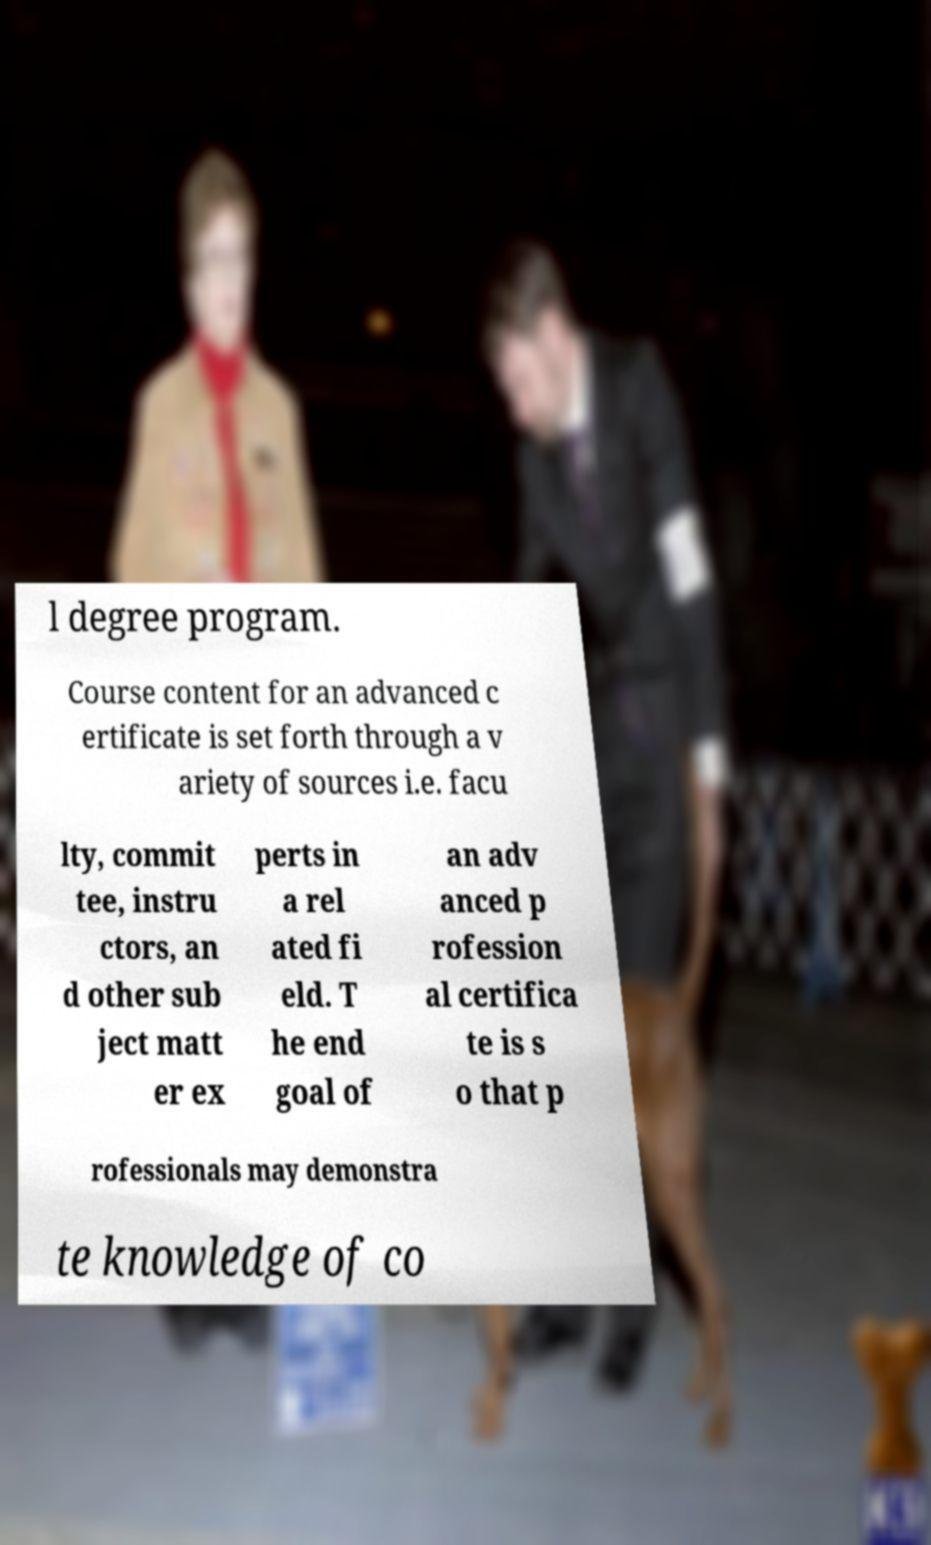Could you extract and type out the text from this image? l degree program. Course content for an advanced c ertificate is set forth through a v ariety of sources i.e. facu lty, commit tee, instru ctors, an d other sub ject matt er ex perts in a rel ated fi eld. T he end goal of an adv anced p rofession al certifica te is s o that p rofessionals may demonstra te knowledge of co 